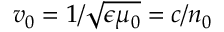Convert formula to latex. <formula><loc_0><loc_0><loc_500><loc_500>v _ { 0 } = 1 / \sqrt { \epsilon \mu _ { 0 } } = c / n _ { 0 }</formula> 